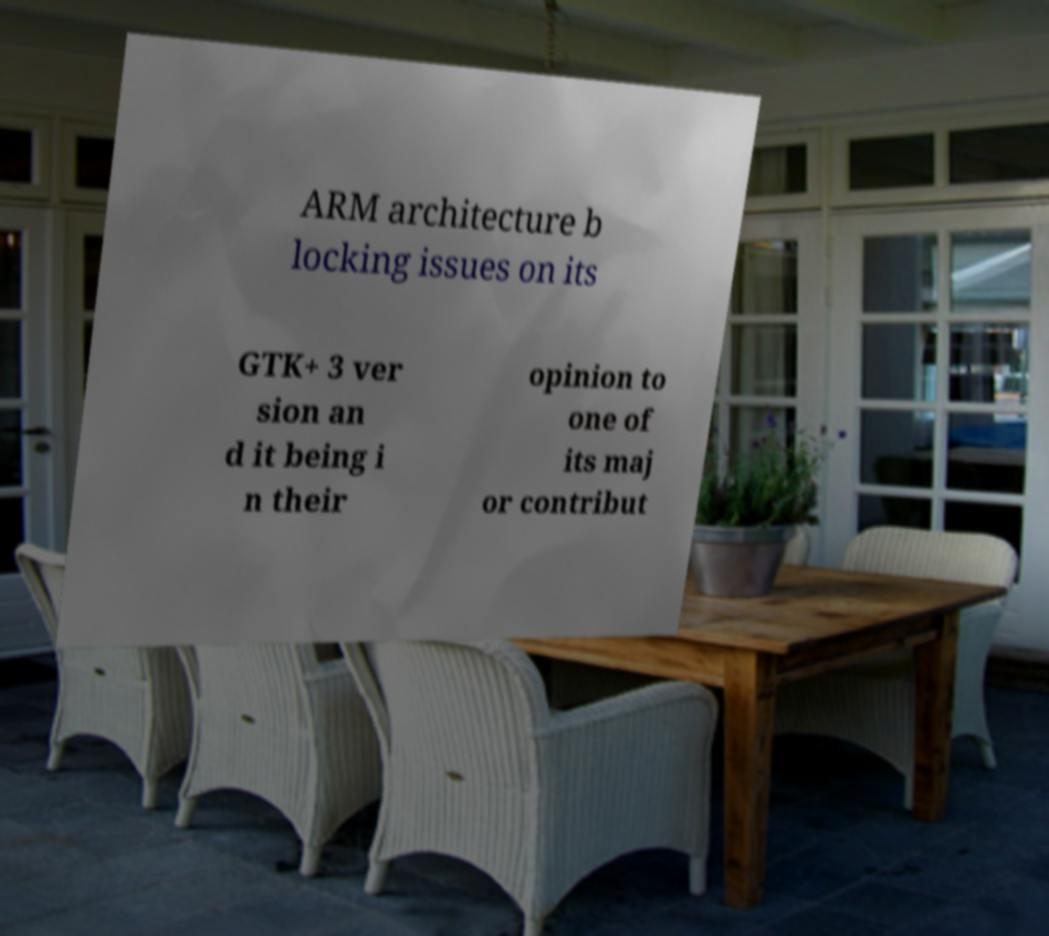For documentation purposes, I need the text within this image transcribed. Could you provide that? ARM architecture b locking issues on its GTK+ 3 ver sion an d it being i n their opinion to one of its maj or contribut 